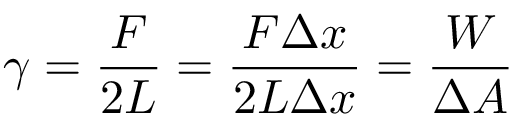Convert formula to latex. <formula><loc_0><loc_0><loc_500><loc_500>\gamma = { \frac { F } { 2 L } } = { \frac { F \Delta x } { 2 L \Delta x } } = { \frac { W } { \Delta A } }</formula> 